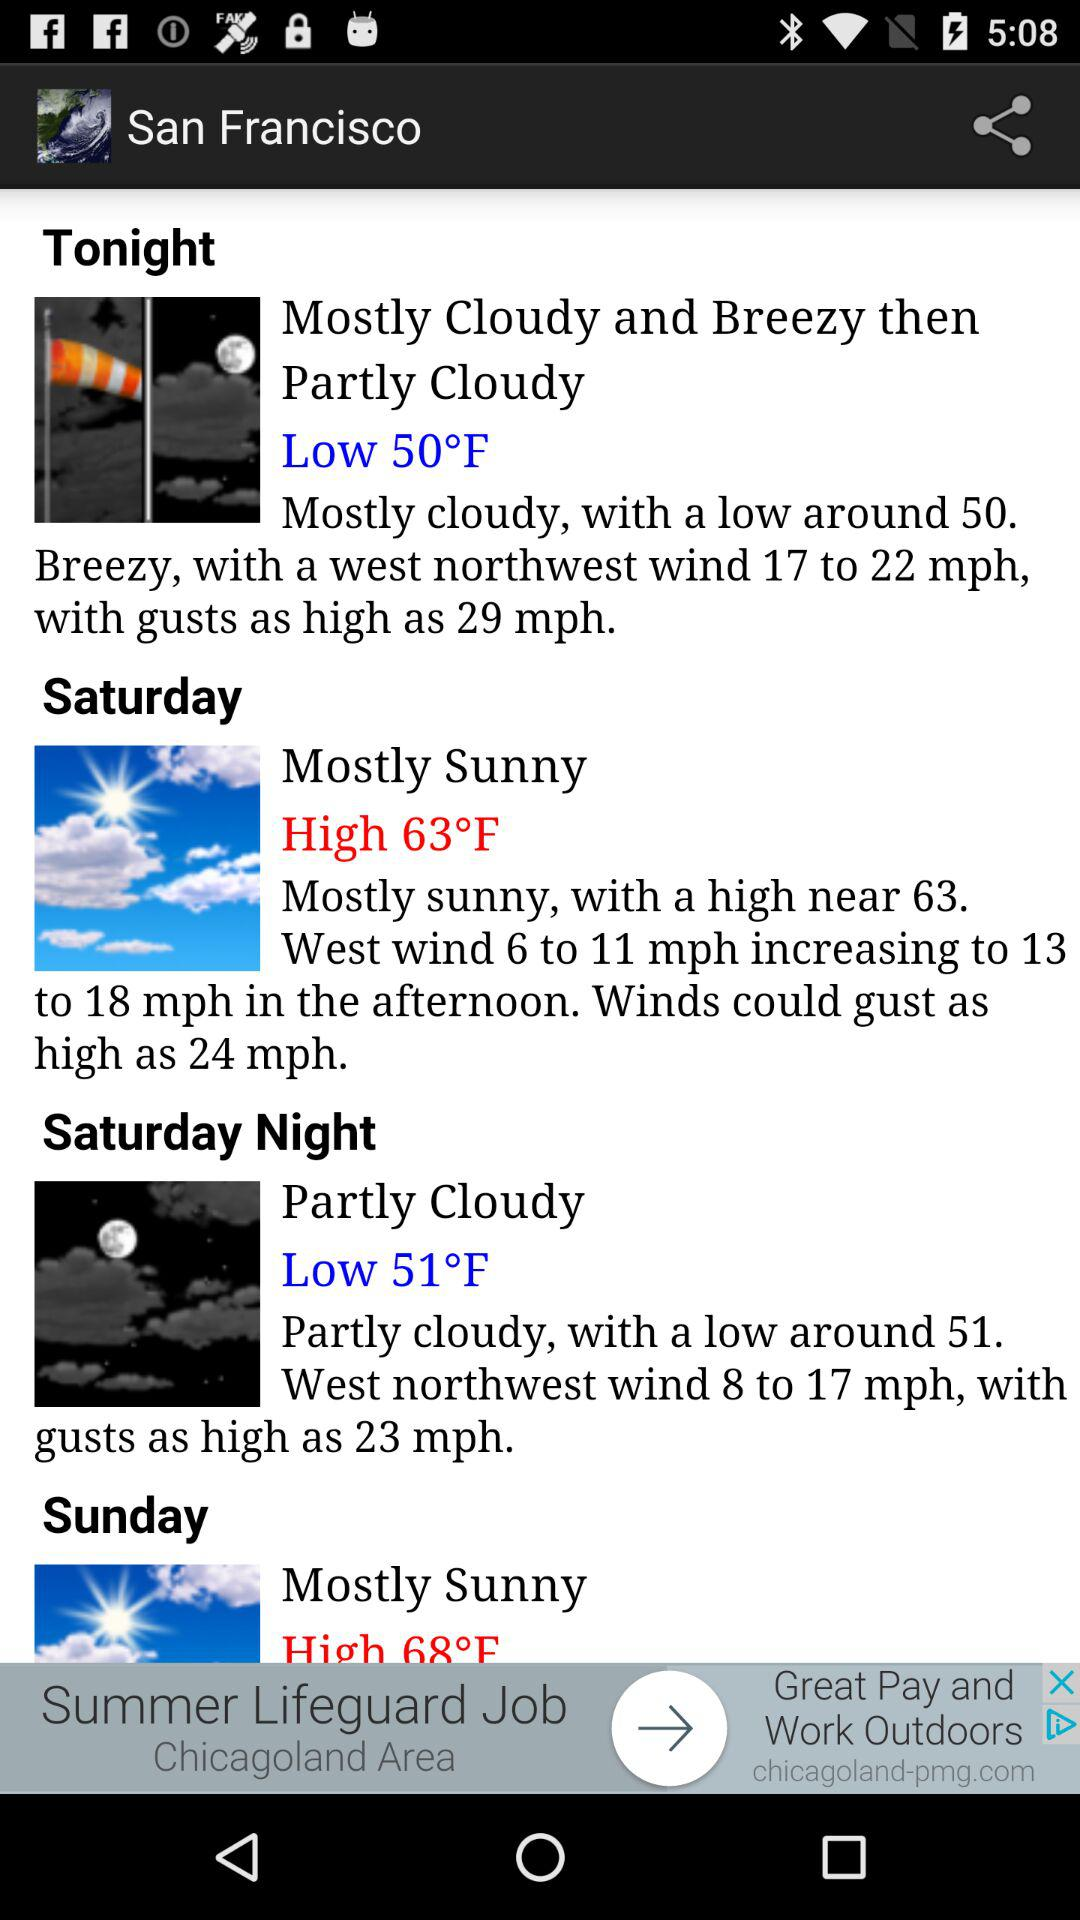What is the temperature tonight? The temperature is 50°F. 